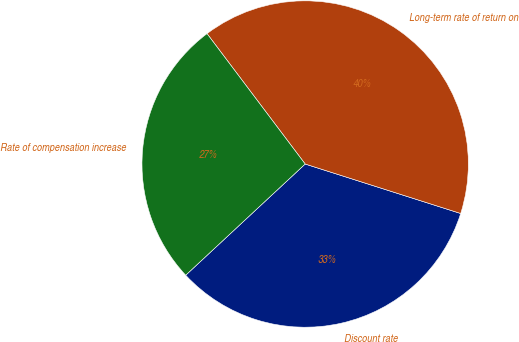<chart> <loc_0><loc_0><loc_500><loc_500><pie_chart><fcel>Discount rate<fcel>Long-term rate of return on<fcel>Rate of compensation increase<nl><fcel>33.17%<fcel>40.17%<fcel>26.66%<nl></chart> 